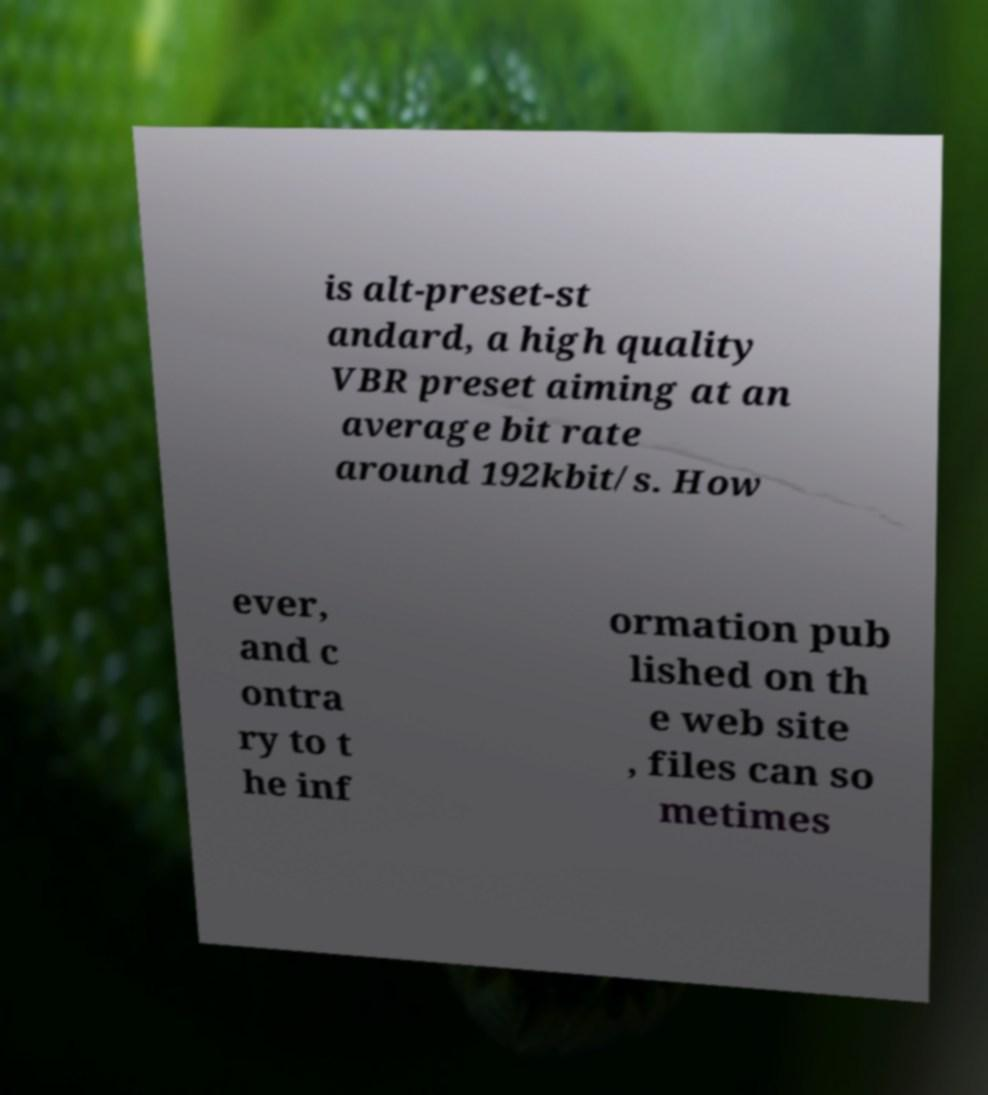Please identify and transcribe the text found in this image. is alt-preset-st andard, a high quality VBR preset aiming at an average bit rate around 192kbit/s. How ever, and c ontra ry to t he inf ormation pub lished on th e web site , files can so metimes 